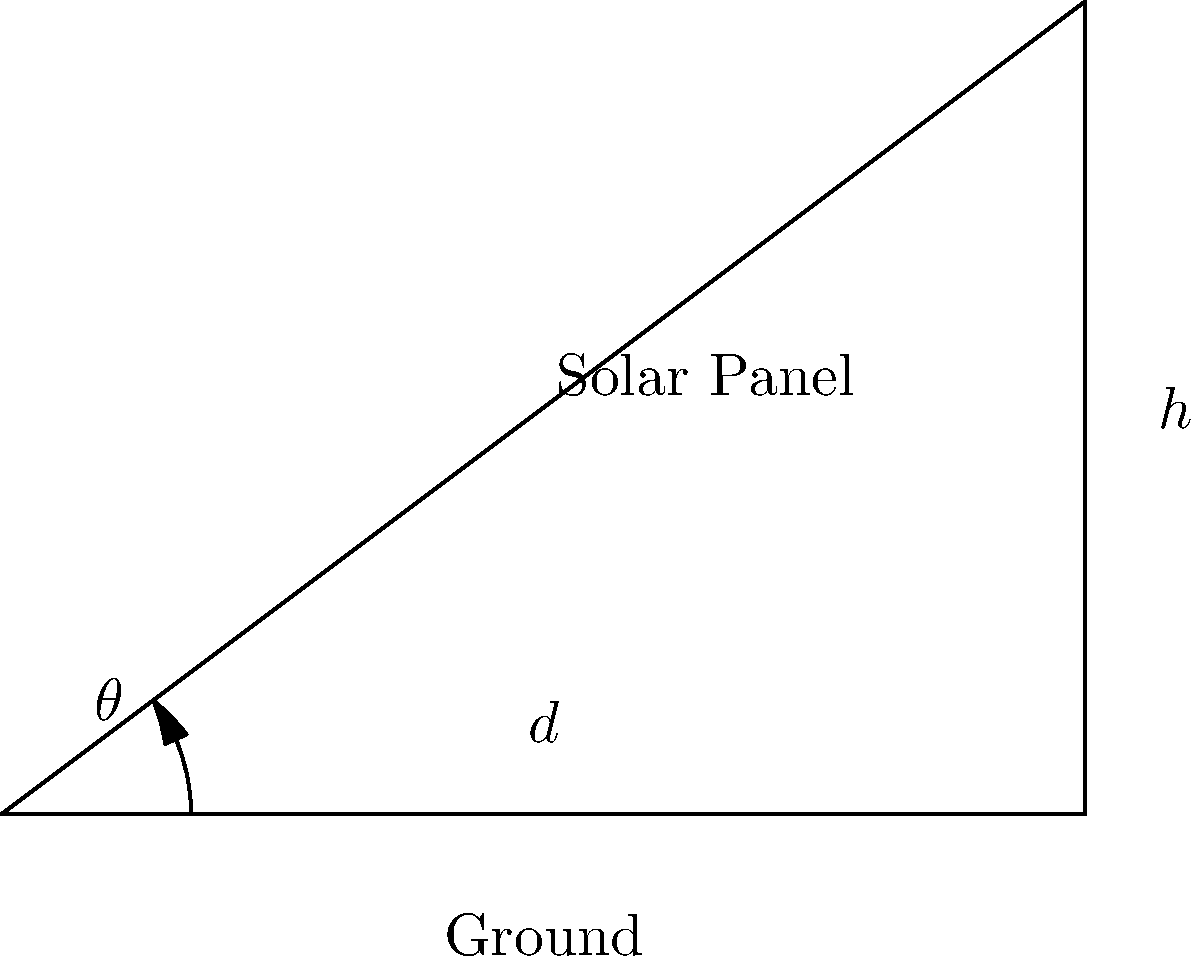As a Java developer optimizing a solar panel system, you need to calculate the optimal angle for maximum energy efficiency. Given a solar panel of length 5 meters and a desired height (h) of 3 meters from the ground, determine the angle $\theta$ (in degrees) at which the panel should be tilted. Use the arctangent function and round your answer to the nearest degree. To solve this problem, we'll use trigonometry and follow these steps:

1. Identify the known variables:
   - Height (h) = 3 meters
   - Length of solar panel = 5 meters

2. Recognize that we have a right triangle where:
   - The hypotenuse is the length of the solar panel (5 meters)
   - The opposite side is the height (h = 3 meters)
   - The adjacent side (d) is unknown, but not needed for this calculation

3. To find the angle $\theta$, we'll use the arctangent function:
   $$\theta = \arctan(\frac{\text{opposite}}{\text{adjacent}})$$

4. In this case, we can use the ratio of height to the length of the panel:
   $$\theta = \arctan(\frac{h}{\text{panel length}})$$

5. Substituting the values:
   $$\theta = \arctan(\frac{3}{5})$$

6. Calculate the result:
   $$\theta \approx 0.5404 \text{ radians}$$

7. Convert radians to degrees:
   $$\theta \approx 0.5404 * \frac{180}{\pi} \approx 30.96 \text{ degrees}$$

8. Round to the nearest degree:
   $$\theta \approx 31 \text{ degrees}$$

Therefore, the optimal angle for the solar panel is approximately 31 degrees.
Answer: 31 degrees 